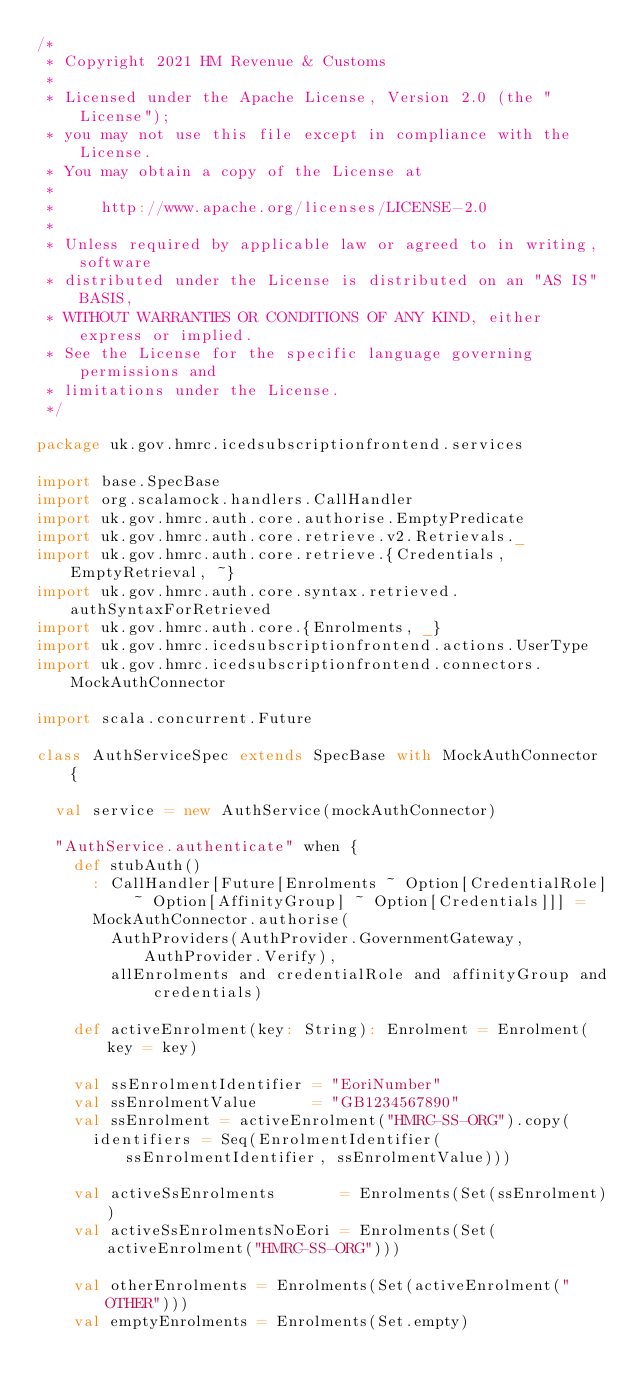Convert code to text. <code><loc_0><loc_0><loc_500><loc_500><_Scala_>/*
 * Copyright 2021 HM Revenue & Customs
 *
 * Licensed under the Apache License, Version 2.0 (the "License");
 * you may not use this file except in compliance with the License.
 * You may obtain a copy of the License at
 *
 *     http://www.apache.org/licenses/LICENSE-2.0
 *
 * Unless required by applicable law or agreed to in writing, software
 * distributed under the License is distributed on an "AS IS" BASIS,
 * WITHOUT WARRANTIES OR CONDITIONS OF ANY KIND, either express or implied.
 * See the License for the specific language governing permissions and
 * limitations under the License.
 */

package uk.gov.hmrc.icedsubscriptionfrontend.services

import base.SpecBase
import org.scalamock.handlers.CallHandler
import uk.gov.hmrc.auth.core.authorise.EmptyPredicate
import uk.gov.hmrc.auth.core.retrieve.v2.Retrievals._
import uk.gov.hmrc.auth.core.retrieve.{Credentials, EmptyRetrieval, ~}
import uk.gov.hmrc.auth.core.syntax.retrieved.authSyntaxForRetrieved
import uk.gov.hmrc.auth.core.{Enrolments, _}
import uk.gov.hmrc.icedsubscriptionfrontend.actions.UserType
import uk.gov.hmrc.icedsubscriptionfrontend.connectors.MockAuthConnector

import scala.concurrent.Future

class AuthServiceSpec extends SpecBase with MockAuthConnector {

  val service = new AuthService(mockAuthConnector)

  "AuthService.authenticate" when {
    def stubAuth()
      : CallHandler[Future[Enrolments ~ Option[CredentialRole] ~ Option[AffinityGroup] ~ Option[Credentials]]] =
      MockAuthConnector.authorise(
        AuthProviders(AuthProvider.GovernmentGateway, AuthProvider.Verify),
        allEnrolments and credentialRole and affinityGroup and credentials)

    def activeEnrolment(key: String): Enrolment = Enrolment(key = key)

    val ssEnrolmentIdentifier = "EoriNumber"
    val ssEnrolmentValue      = "GB1234567890"
    val ssEnrolment = activeEnrolment("HMRC-SS-ORG").copy(
      identifiers = Seq(EnrolmentIdentifier(ssEnrolmentIdentifier, ssEnrolmentValue)))

    val activeSsEnrolments       = Enrolments(Set(ssEnrolment))
    val activeSsEnrolmentsNoEori = Enrolments(Set(activeEnrolment("HMRC-SS-ORG")))

    val otherEnrolments = Enrolments(Set(activeEnrolment("OTHER")))
    val emptyEnrolments = Enrolments(Set.empty)
</code> 